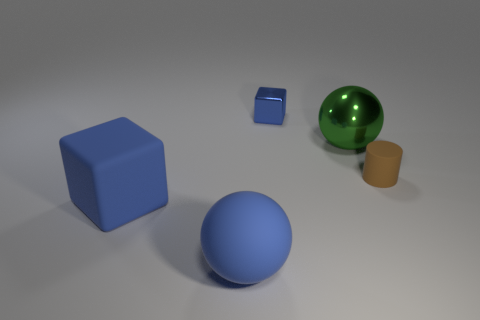What shape is the brown object that is the same material as the blue ball?
Keep it short and to the point. Cylinder. There is a small matte object; is it the same shape as the metal thing behind the large green object?
Offer a very short reply. No. There is a tiny thing that is behind the large sphere on the right side of the tiny block; what is its material?
Provide a succinct answer. Metal. How many other objects are there of the same shape as the brown rubber thing?
Your response must be concise. 0. There is a blue thing behind the brown cylinder; is it the same shape as the big matte object that is in front of the rubber cube?
Keep it short and to the point. No. Is there anything else that is the same material as the tiny cylinder?
Your answer should be compact. Yes. What is the material of the tiny block?
Your answer should be compact. Metal. There is a cube right of the big block; what is it made of?
Ensure brevity in your answer.  Metal. Is there anything else that has the same color as the cylinder?
Ensure brevity in your answer.  No. What size is the blue block that is the same material as the blue sphere?
Offer a very short reply. Large. 